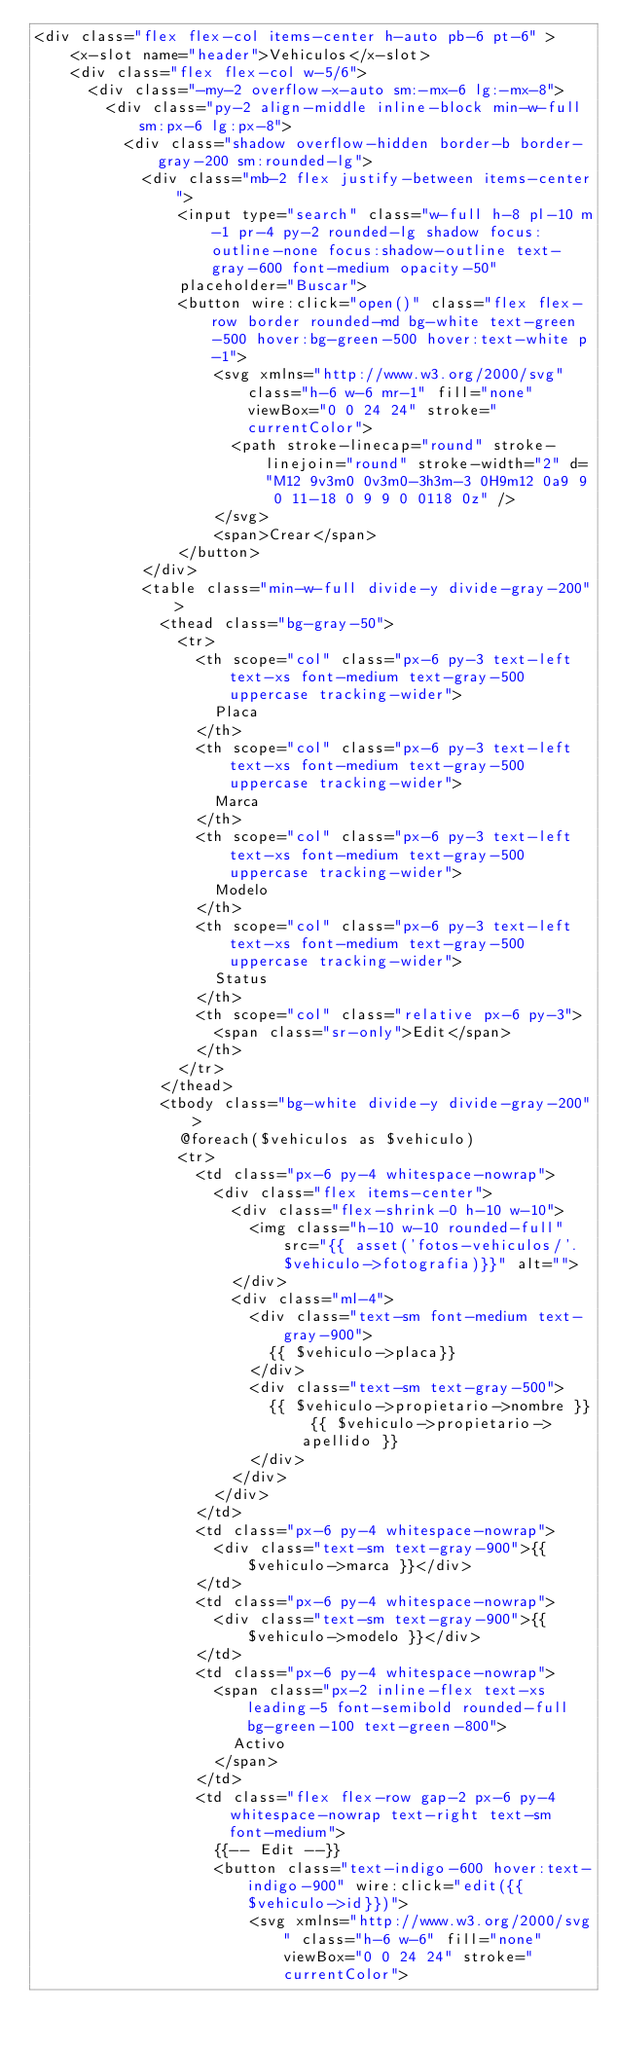Convert code to text. <code><loc_0><loc_0><loc_500><loc_500><_PHP_><div class="flex flex-col items-center h-auto pb-6 pt-6" >
    <x-slot name="header">Vehiculos</x-slot>
    <div class="flex flex-col w-5/6">
      <div class="-my-2 overflow-x-auto sm:-mx-6 lg:-mx-8">
        <div class="py-2 align-middle inline-block min-w-full sm:px-6 lg:px-8">
          <div class="shadow overflow-hidden border-b border-gray-200 sm:rounded-lg">
            <div class="mb-2 flex justify-between items-center">
                <input type="search" class="w-full h-8 pl-10 m-1 pr-4 py-2 rounded-lg shadow focus:outline-none focus:shadow-outline text-gray-600 font-medium opacity-50"
                placeholder="Buscar">
                <button wire:click="open()" class="flex flex-row border rounded-md bg-white text-green-500 hover:bg-green-500 hover:text-white p-1">
                    <svg xmlns="http://www.w3.org/2000/svg" class="h-6 w-6 mr-1" fill="none" viewBox="0 0 24 24" stroke="currentColor">
                      <path stroke-linecap="round" stroke-linejoin="round" stroke-width="2" d="M12 9v3m0 0v3m0-3h3m-3 0H9m12 0a9 9 0 11-18 0 9 9 0 0118 0z" />
                    </svg>
                    <span>Crear</span>
                </button>
            </div>
            <table class="min-w-full divide-y divide-gray-200">
              <thead class="bg-gray-50">
                <tr>
                  <th scope="col" class="px-6 py-3 text-left text-xs font-medium text-gray-500 uppercase tracking-wider">
                    Placa
                  </th>
                  <th scope="col" class="px-6 py-3 text-left text-xs font-medium text-gray-500 uppercase tracking-wider">
                    Marca
                  </th>
                  <th scope="col" class="px-6 py-3 text-left text-xs font-medium text-gray-500 uppercase tracking-wider">
                    Modelo
                  </th>
                  <th scope="col" class="px-6 py-3 text-left text-xs font-medium text-gray-500 uppercase tracking-wider">
                    Status
                  </th>
                  <th scope="col" class="relative px-6 py-3">
                    <span class="sr-only">Edit</span>
                  </th>
                </tr>
              </thead>
              <tbody class="bg-white divide-y divide-gray-200">
                @foreach($vehiculos as $vehiculo)
                <tr>
                  <td class="px-6 py-4 whitespace-nowrap">
                    <div class="flex items-center">
                      <div class="flex-shrink-0 h-10 w-10">
                        <img class="h-10 w-10 rounded-full" src="{{ asset('fotos-vehiculos/'. $vehiculo->fotografia)}}" alt="">
                      </div>
                      <div class="ml-4">
                        <div class="text-sm font-medium text-gray-900">
                          {{ $vehiculo->placa}}
                        </div>
                        <div class="text-sm text-gray-500">
                          {{ $vehiculo->propietario->nombre }} {{ $vehiculo->propietario->apellido }}
                        </div>
                      </div>
                    </div>
                  </td>
                  <td class="px-6 py-4 whitespace-nowrap">
                    <div class="text-sm text-gray-900">{{ $vehiculo->marca }}</div>
                  </td>
                  <td class="px-6 py-4 whitespace-nowrap">
                    <div class="text-sm text-gray-900">{{ $vehiculo->modelo }}</div>
                  </td>
                  <td class="px-6 py-4 whitespace-nowrap">
                    <span class="px-2 inline-flex text-xs leading-5 font-semibold rounded-full bg-green-100 text-green-800">
                      Activo
                    </span>
                  </td>
                  <td class="flex flex-row gap-2 px-6 py-4 whitespace-nowrap text-right text-sm font-medium">
                    {{-- Edit --}}
                    <button class="text-indigo-600 hover:text-indigo-900" wire:click="edit({{$vehiculo->id}})">
                        <svg xmlns="http://www.w3.org/2000/svg" class="h-6 w-6" fill="none" viewBox="0 0 24 24" stroke="currentColor"></code> 